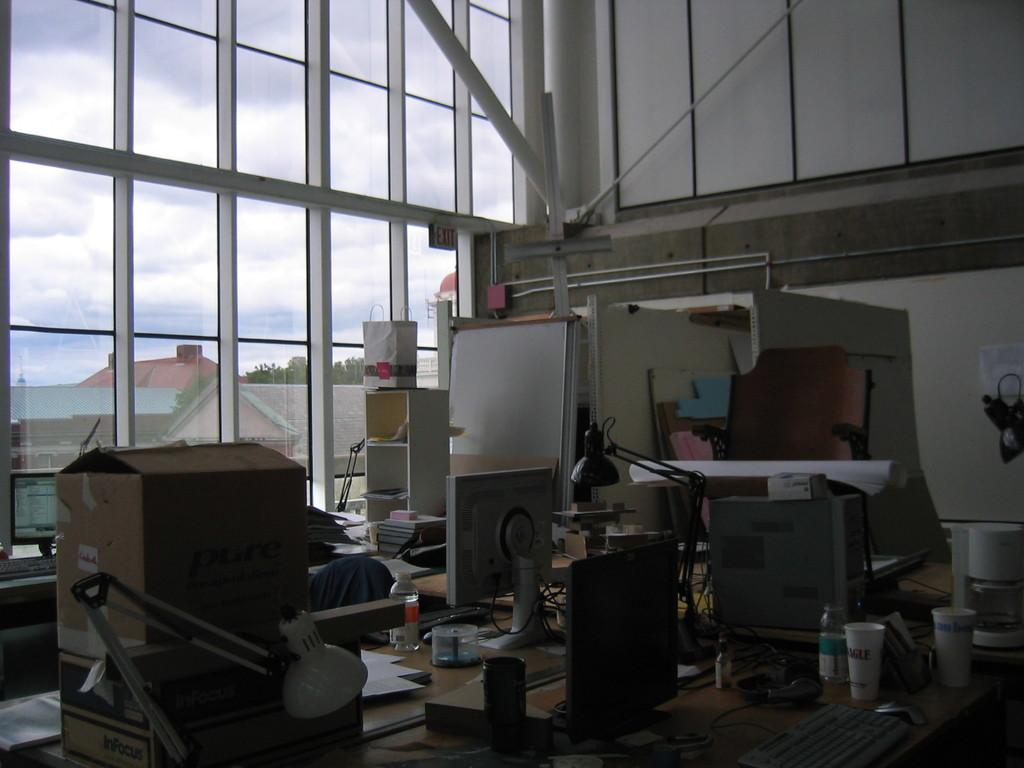What electronic devices are present in the image? There are computers in the image. What is on the table in the image? There are objects on the table in the image. What can be seen in the distance in the image? There are houses and a tree visible in the background of the image. What is visible through the window in the background of the image? There are clouds in the sky visible through a window in the background of the image. What type of crown is placed on the table in the image? There is no crown present on the table in the image. What kind of wine is being served in the image? There is no wine present in the image. 